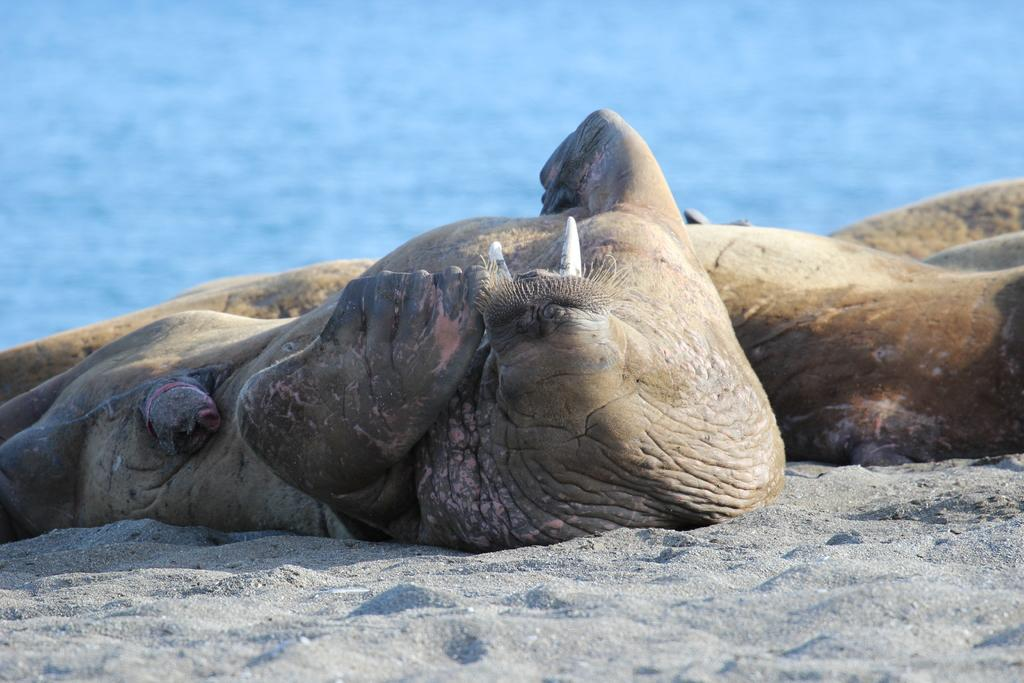What types of living organisms can be seen in the image? There are animals in the image. What type of terrain is visible in the image? Soil is present in the image. What natural element is visible in the image? Water is visible in the image. What type of car can be seen driving through the gate in the image? There is no car or gate present in the image; it features animals, soil, and water. What type of waste is visible in the image? There is no waste visible in the image; it features animals, soil, and water. 